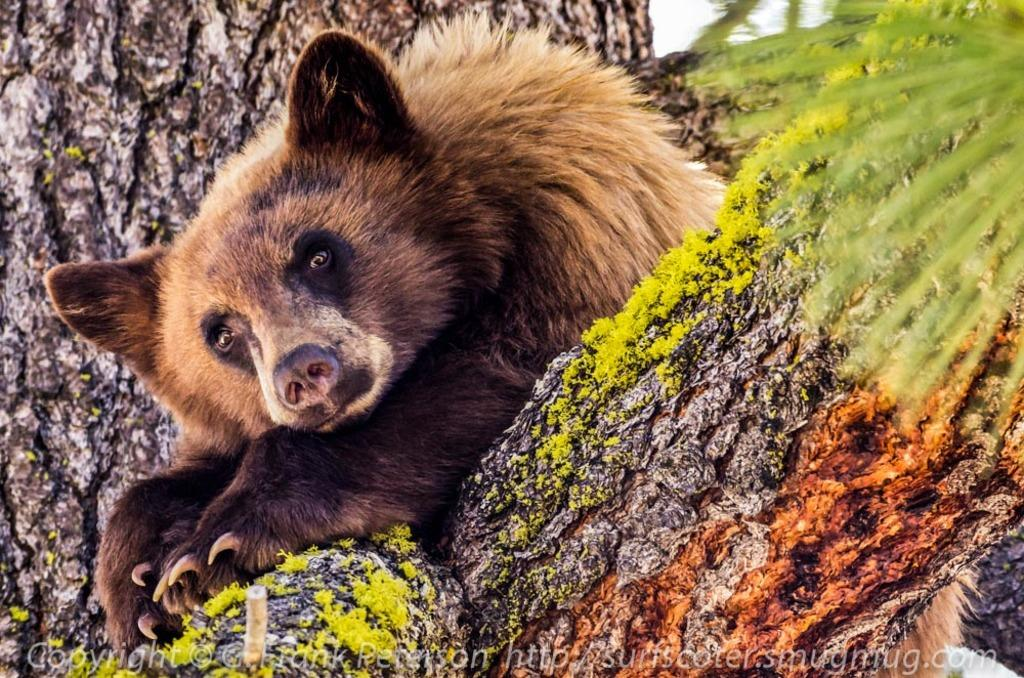What animal is sitting on the tree in the image? There is a bear sitting on the tree in the image. What can be seen on the branch of the tree? There are mosses on the branch of the tree. What is present at the bottom of the image? There is some text at the bottom of the image. What type of chicken is being polished in the image? There is no chicken present in the image, nor is there any mention of polishing. 